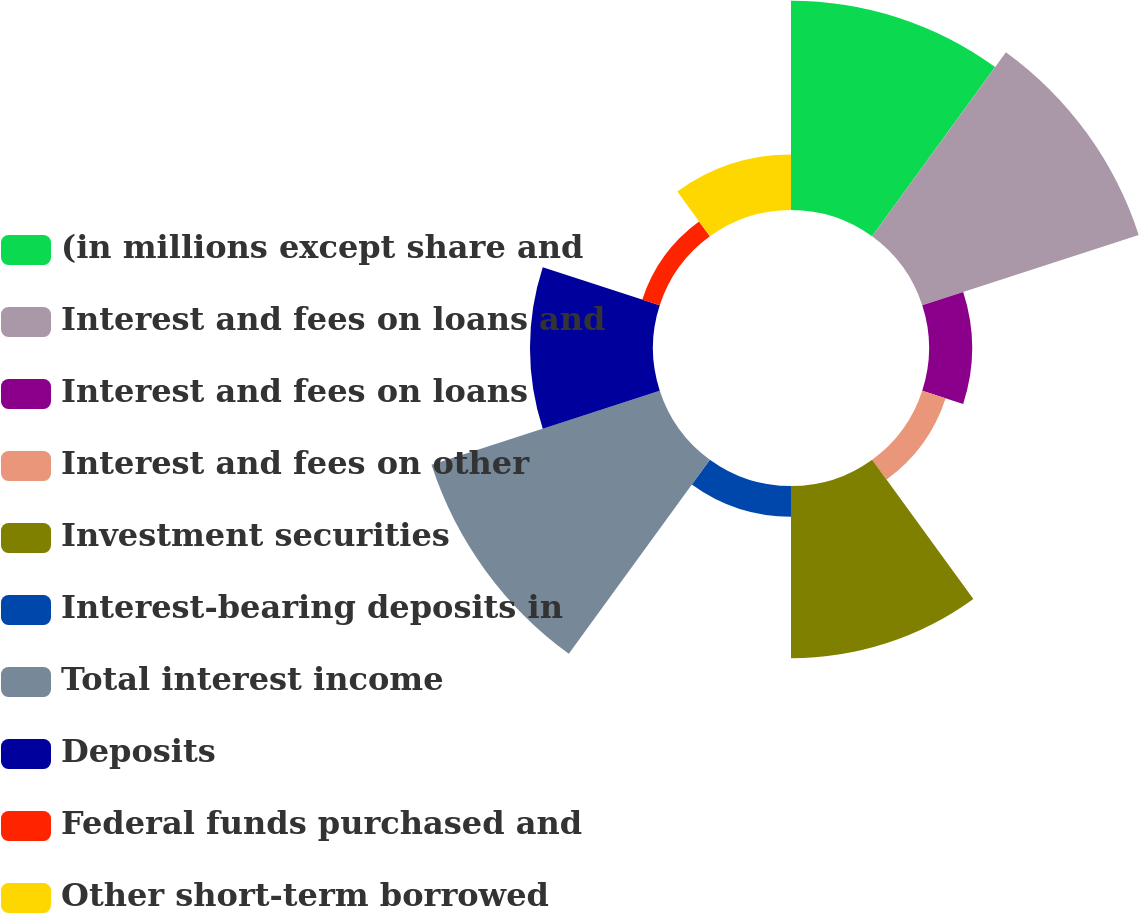<chart> <loc_0><loc_0><loc_500><loc_500><pie_chart><fcel>(in millions except share and<fcel>Interest and fees on loans and<fcel>Interest and fees on loans<fcel>Interest and fees on other<fcel>Investment securities<fcel>Interest-bearing deposits in<fcel>Total interest income<fcel>Deposits<fcel>Federal funds purchased and<fcel>Other short-term borrowed<nl><fcel>18.28%<fcel>19.89%<fcel>3.76%<fcel>2.15%<fcel>15.05%<fcel>2.69%<fcel>20.97%<fcel>10.75%<fcel>1.61%<fcel>4.84%<nl></chart> 